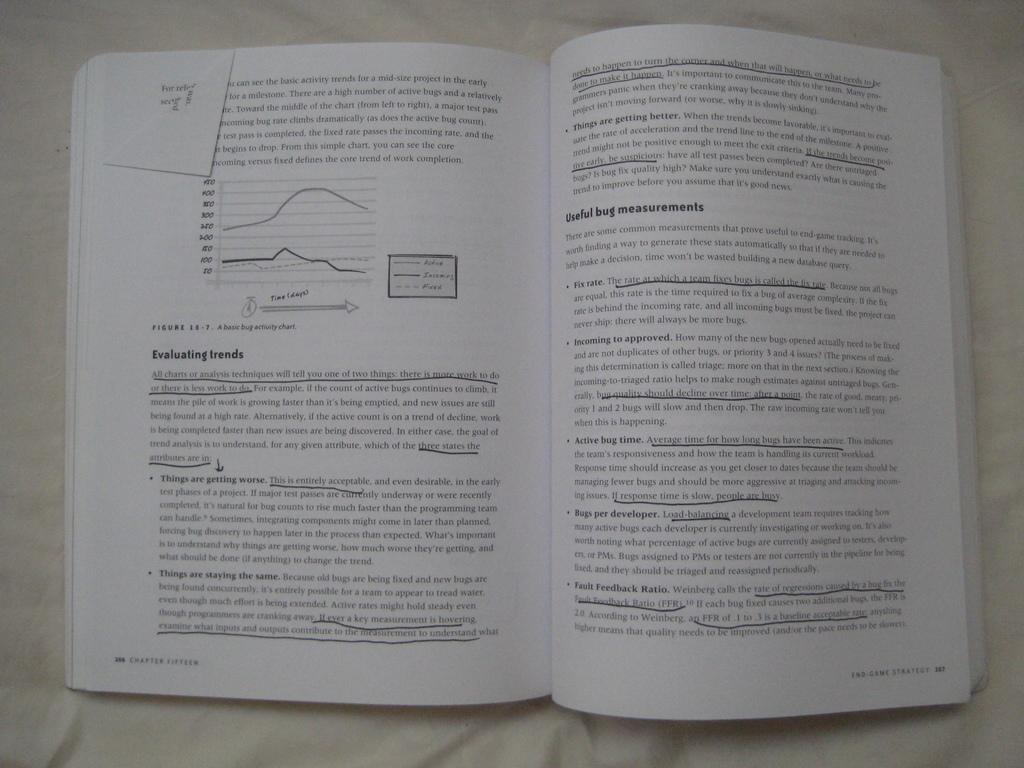<image>
Give a short and clear explanation of the subsequent image. a book is highlighted under a paragraph on Evaluating Trends 